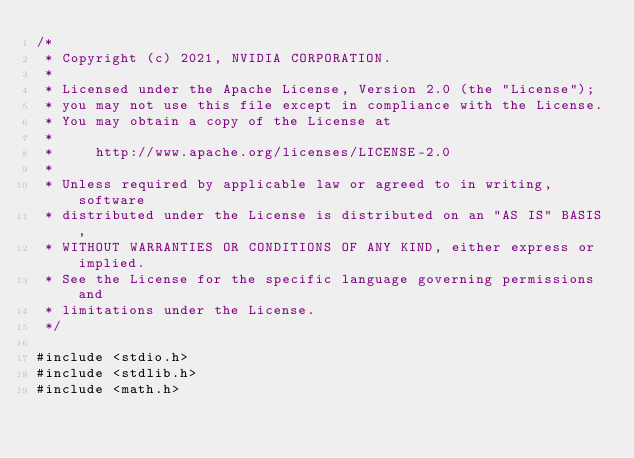<code> <loc_0><loc_0><loc_500><loc_500><_Cuda_>/*
 * Copyright (c) 2021, NVIDIA CORPORATION.
 *
 * Licensed under the Apache License, Version 2.0 (the "License");
 * you may not use this file except in compliance with the License.
 * You may obtain a copy of the License at
 *
 *     http://www.apache.org/licenses/LICENSE-2.0
 *
 * Unless required by applicable law or agreed to in writing, software
 * distributed under the License is distributed on an "AS IS" BASIS,
 * WITHOUT WARRANTIES OR CONDITIONS OF ANY KIND, either express or implied.
 * See the License for the specific language governing permissions and
 * limitations under the License.
 */

#include <stdio.h>
#include <stdlib.h>
#include <math.h></code> 